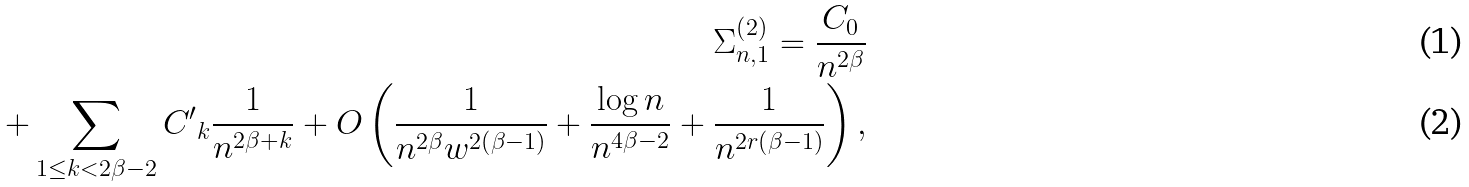<formula> <loc_0><loc_0><loc_500><loc_500>\Sigma _ { n , 1 } ^ { \left ( 2 \right ) } = \frac { C _ { 0 } } { n ^ { 2 \beta } } \\ + \sum _ { 1 \leq k < 2 \beta - 2 } { C ^ { \prime } } _ { k } \frac { 1 } { n ^ { 2 \beta + k } } + O \left ( \frac { 1 } { n ^ { 2 \beta } w ^ { 2 \left ( \beta - 1 \right ) } } + \frac { \log n } { n ^ { 4 \beta - 2 } } + \frac { 1 } { n ^ { 2 r \left ( \beta - 1 \right ) } } \right ) ,</formula> 